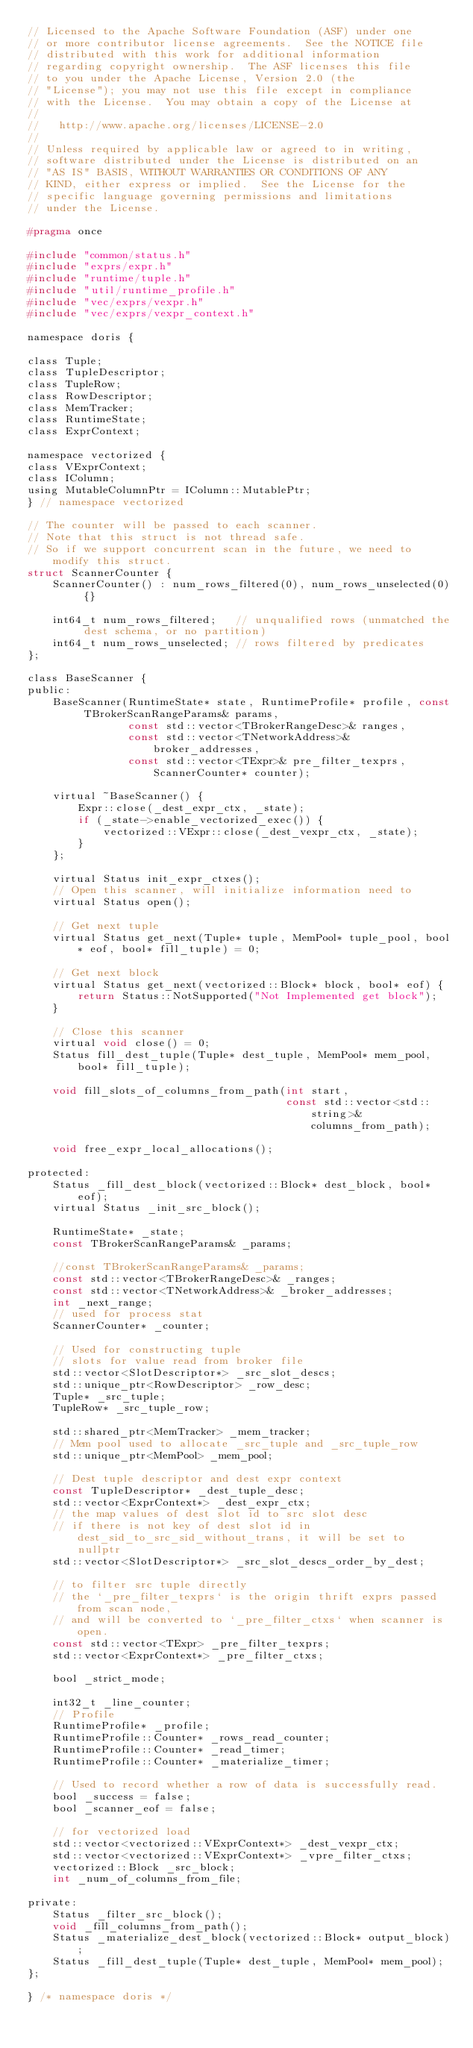<code> <loc_0><loc_0><loc_500><loc_500><_C_>// Licensed to the Apache Software Foundation (ASF) under one
// or more contributor license agreements.  See the NOTICE file
// distributed with this work for additional information
// regarding copyright ownership.  The ASF licenses this file
// to you under the Apache License, Version 2.0 (the
// "License"); you may not use this file except in compliance
// with the License.  You may obtain a copy of the License at
//
//   http://www.apache.org/licenses/LICENSE-2.0
//
// Unless required by applicable law or agreed to in writing,
// software distributed under the License is distributed on an
// "AS IS" BASIS, WITHOUT WARRANTIES OR CONDITIONS OF ANY
// KIND, either express or implied.  See the License for the
// specific language governing permissions and limitations
// under the License.

#pragma once

#include "common/status.h"
#include "exprs/expr.h"
#include "runtime/tuple.h"
#include "util/runtime_profile.h"
#include "vec/exprs/vexpr.h"
#include "vec/exprs/vexpr_context.h"

namespace doris {

class Tuple;
class TupleDescriptor;
class TupleRow;
class RowDescriptor;
class MemTracker;
class RuntimeState;
class ExprContext;

namespace vectorized {
class VExprContext;
class IColumn;
using MutableColumnPtr = IColumn::MutablePtr;
} // namespace vectorized

// The counter will be passed to each scanner.
// Note that this struct is not thread safe.
// So if we support concurrent scan in the future, we need to modify this struct.
struct ScannerCounter {
    ScannerCounter() : num_rows_filtered(0), num_rows_unselected(0) {}

    int64_t num_rows_filtered;   // unqualified rows (unmatched the dest schema, or no partition)
    int64_t num_rows_unselected; // rows filtered by predicates
};

class BaseScanner {
public:
    BaseScanner(RuntimeState* state, RuntimeProfile* profile, const TBrokerScanRangeParams& params,
                const std::vector<TBrokerRangeDesc>& ranges,
                const std::vector<TNetworkAddress>& broker_addresses,
                const std::vector<TExpr>& pre_filter_texprs, ScannerCounter* counter);

    virtual ~BaseScanner() {
        Expr::close(_dest_expr_ctx, _state);
        if (_state->enable_vectorized_exec()) {
            vectorized::VExpr::close(_dest_vexpr_ctx, _state);
        }
    };

    virtual Status init_expr_ctxes();
    // Open this scanner, will initialize information need to
    virtual Status open();

    // Get next tuple
    virtual Status get_next(Tuple* tuple, MemPool* tuple_pool, bool* eof, bool* fill_tuple) = 0;

    // Get next block
    virtual Status get_next(vectorized::Block* block, bool* eof) {
        return Status::NotSupported("Not Implemented get block");
    }

    // Close this scanner
    virtual void close() = 0;
    Status fill_dest_tuple(Tuple* dest_tuple, MemPool* mem_pool, bool* fill_tuple);

    void fill_slots_of_columns_from_path(int start,
                                         const std::vector<std::string>& columns_from_path);

    void free_expr_local_allocations();

protected:
    Status _fill_dest_block(vectorized::Block* dest_block, bool* eof);
    virtual Status _init_src_block();

    RuntimeState* _state;
    const TBrokerScanRangeParams& _params;

    //const TBrokerScanRangeParams& _params;
    const std::vector<TBrokerRangeDesc>& _ranges;
    const std::vector<TNetworkAddress>& _broker_addresses;
    int _next_range;
    // used for process stat
    ScannerCounter* _counter;

    // Used for constructing tuple
    // slots for value read from broker file
    std::vector<SlotDescriptor*> _src_slot_descs;
    std::unique_ptr<RowDescriptor> _row_desc;
    Tuple* _src_tuple;
    TupleRow* _src_tuple_row;

    std::shared_ptr<MemTracker> _mem_tracker;
    // Mem pool used to allocate _src_tuple and _src_tuple_row
    std::unique_ptr<MemPool> _mem_pool;

    // Dest tuple descriptor and dest expr context
    const TupleDescriptor* _dest_tuple_desc;
    std::vector<ExprContext*> _dest_expr_ctx;
    // the map values of dest slot id to src slot desc
    // if there is not key of dest slot id in dest_sid_to_src_sid_without_trans, it will be set to nullptr
    std::vector<SlotDescriptor*> _src_slot_descs_order_by_dest;

    // to filter src tuple directly
    // the `_pre_filter_texprs` is the origin thrift exprs passed from scan node,
    // and will be converted to `_pre_filter_ctxs` when scanner is open.
    const std::vector<TExpr> _pre_filter_texprs;
    std::vector<ExprContext*> _pre_filter_ctxs;

    bool _strict_mode;

    int32_t _line_counter;
    // Profile
    RuntimeProfile* _profile;
    RuntimeProfile::Counter* _rows_read_counter;
    RuntimeProfile::Counter* _read_timer;
    RuntimeProfile::Counter* _materialize_timer;

    // Used to record whether a row of data is successfully read.
    bool _success = false;
    bool _scanner_eof = false;

    // for vectorized load
    std::vector<vectorized::VExprContext*> _dest_vexpr_ctx;
    std::vector<vectorized::VExprContext*> _vpre_filter_ctxs;
    vectorized::Block _src_block;
    int _num_of_columns_from_file;

private:
    Status _filter_src_block();
    void _fill_columns_from_path();
    Status _materialize_dest_block(vectorized::Block* output_block);
    Status _fill_dest_tuple(Tuple* dest_tuple, MemPool* mem_pool);
};

} /* namespace doris */
</code> 